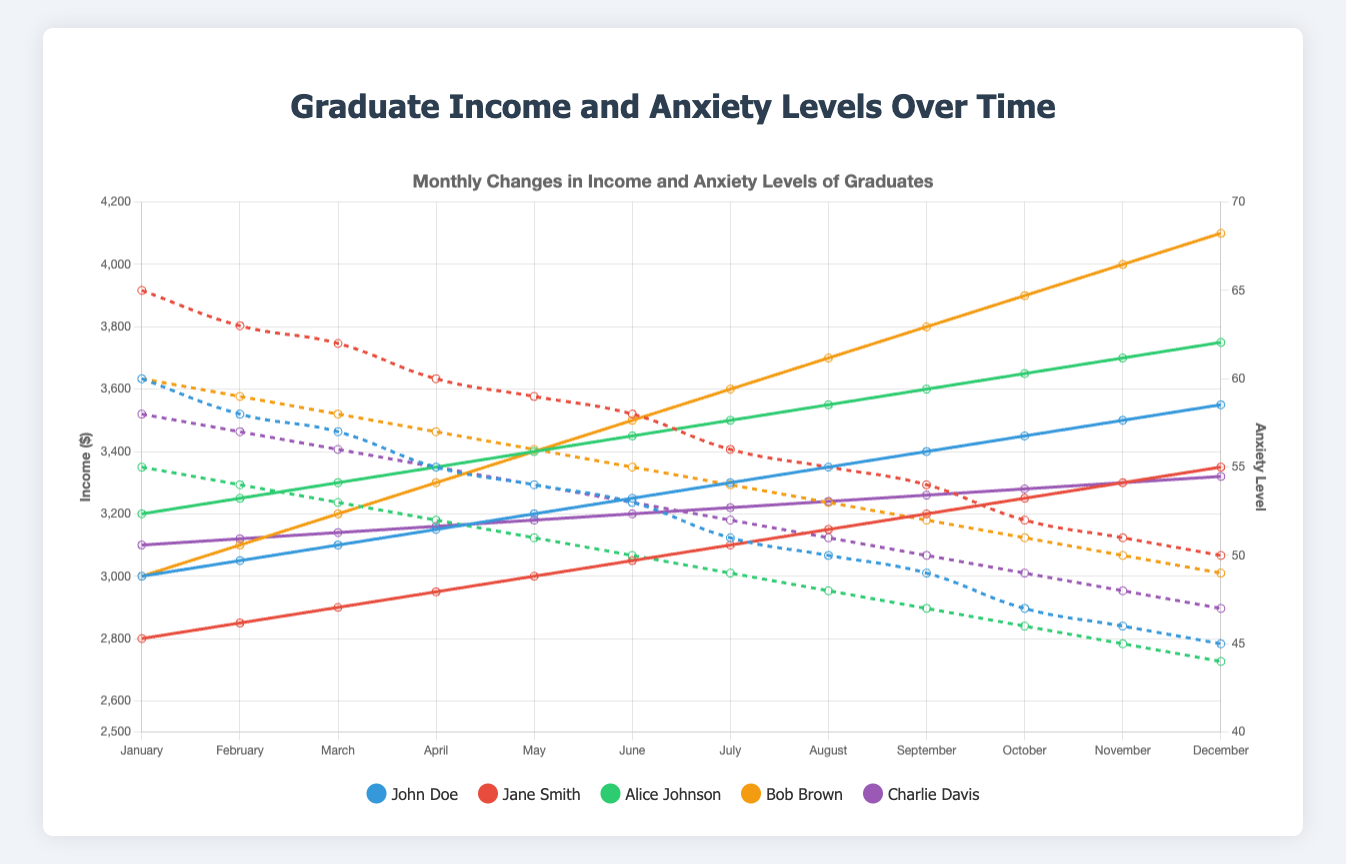What is the general trend of income levels for John Doe throughout the year? By observing John Doe's income line on the chart, it shows a consistent monthly increase from January to December. The income starts at 3000 in January and gradually rises to 3550 by December.
Answer: Increase How do Jane Smith's anxiety levels compare to Bob Brown's in April? Checking the chart, Jane Smith's anxiety level in April is 60 and Bob Brown's is 57. Since 60 is greater than 57, Jane Smith has higher anxiety levels than Bob Brown in April.
Answer: Jane Smith's is higher Among the five graduates, whose income saw the greatest absolute increase over the year? Calculating the difference in income from January to December for each graduate: John Doe (3550 - 3000 = 550), Jane Smith (3350 - 2800 = 550), Alice Johnson (3750 - 3200 = 550), Bob Brown (4100 - 3000 = 1100), and Charlie Davis (3320 - 3100 = 220). Bob Brown has the greatest increase of 1100.
Answer: Bob Brown Which graduate has the least variation in their anxiety levels throughout the year? By looking at the anxiety level lines, Charlie Davis shows a decrease from 58 to 47, which is a difference of 11, while others have larger variations. So, Charlie Davis has the least variation.
Answer: Charlie Davis What is the average income for Alice Johnson in the first quarter (January to March)? Sum of Alice Johnson's income for January, February, and March is 3200 + 3250 + 3300 = 9750. Dividing by 3 months, the average is 9750 / 3 = 3250.
Answer: 3250 Compare the lowest anxiety level of any graduate with the highest income achieved by the same graduate. For Alice Johnson, who has the lowest anxiety level of 44 in December, the corresponding highest income is 3750 in December.
Answer: Alice Johnson - 44 and 3750 Are there any months where all five graduates have decreasing anxiety levels compared to the previous month? Observing the anxiety levels month by month, all graduates have lower anxiety levels in April compared to March.
Answer: April What is the overall trend in the relationship between income and anxiety levels for all graduates? Generally, as income increases, the anxiety levels decrease. This is evident from the majority of the lines showing this inverse relationship on the chart.
Answer: Income up, anxiety down By how much did Charlie Davis' income increase from June to December? Charlie Davis' income in June is 3200 and in December is 3320. The increase is 3320 - 3200 = 120.
Answer: 120 Which graduate had the highest income in June, and what was that amount? Checking the incomes in June, Alice Johnson had the highest income of 3450.
Answer: Alice Johnson, 3450 